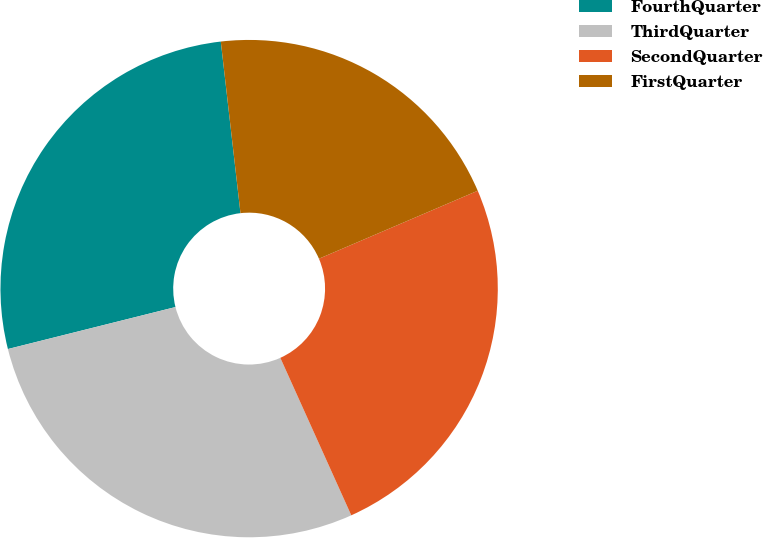Convert chart. <chart><loc_0><loc_0><loc_500><loc_500><pie_chart><fcel>FourthQuarter<fcel>ThirdQuarter<fcel>SecondQuarter<fcel>FirstQuarter<nl><fcel>27.09%<fcel>27.83%<fcel>24.7%<fcel>20.38%<nl></chart> 